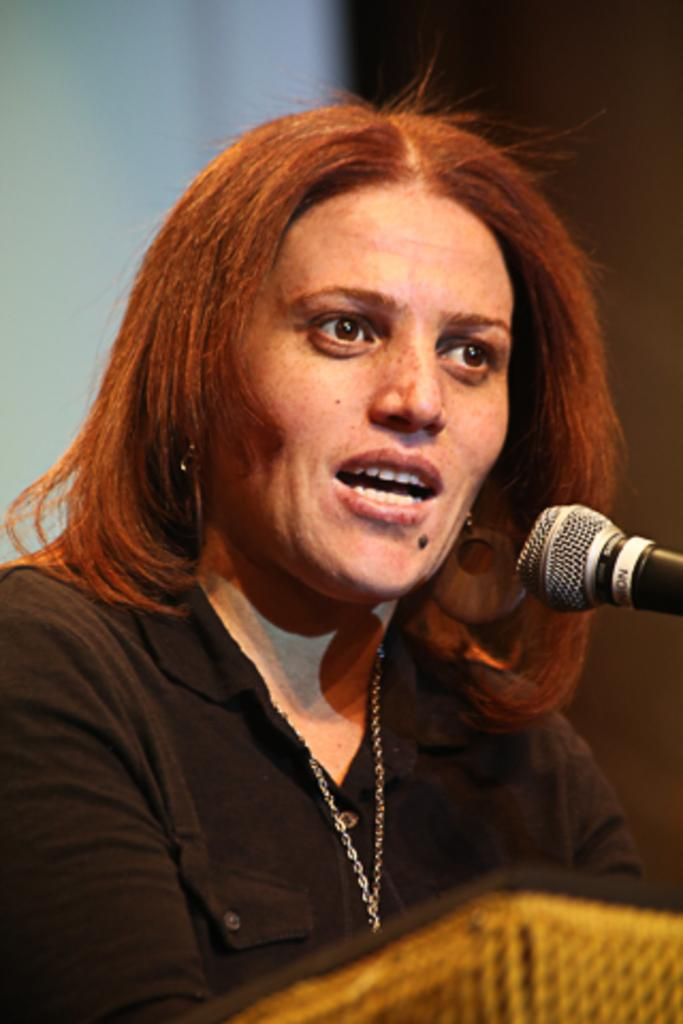Who is the main subject in the image? There is a woman in the image. What is the woman doing in the image? The woman is speaking in front of a microphone. Can you describe the background of the image? The background of the image is blurry. What is the color of the object in the front of the image? The object in the front of the image is brown and black in color. How many roses can be seen in the image? There are no roses present in the image. What type of air is being used by the woman in the image? The image does not provide information about the type of air being used by the woman. 